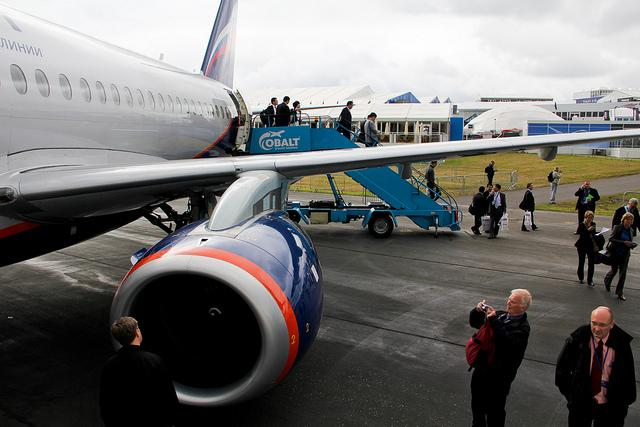What is the man with the red backpack on the right doing? Please explain your reasoning. taking photo. The man is holding a camera visibly and is looking through the lens based on his body position and eye line. someone looking through the lens of a camera is likely to be taking pictures. 